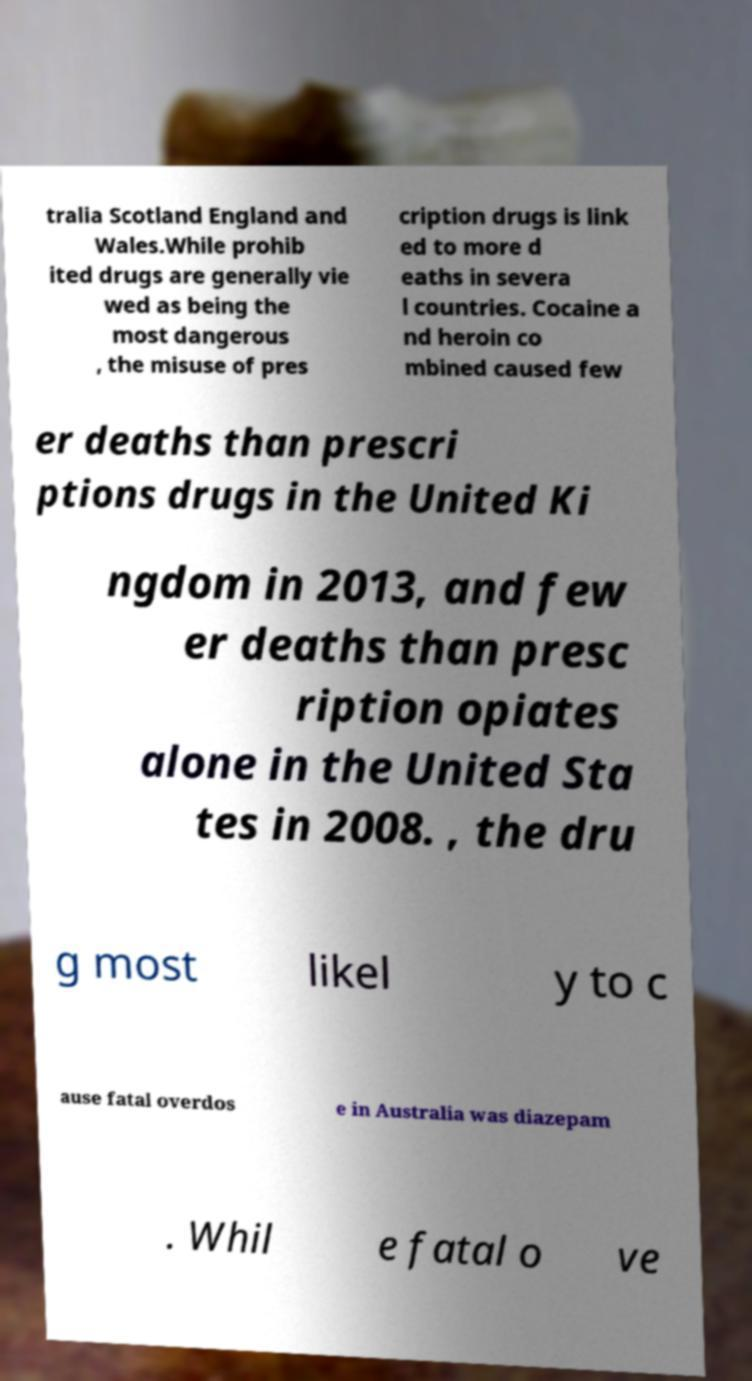There's text embedded in this image that I need extracted. Can you transcribe it verbatim? tralia Scotland England and Wales.While prohib ited drugs are generally vie wed as being the most dangerous , the misuse of pres cription drugs is link ed to more d eaths in severa l countries. Cocaine a nd heroin co mbined caused few er deaths than prescri ptions drugs in the United Ki ngdom in 2013, and few er deaths than presc ription opiates alone in the United Sta tes in 2008. , the dru g most likel y to c ause fatal overdos e in Australia was diazepam . Whil e fatal o ve 